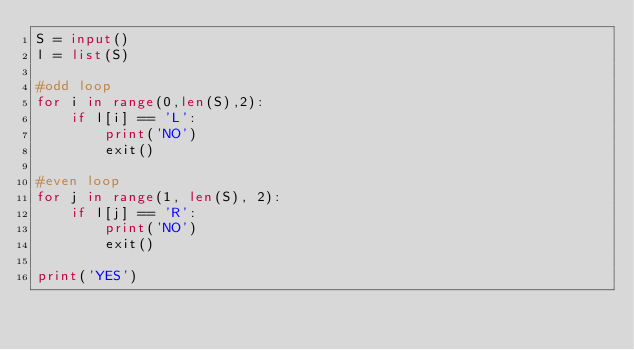<code> <loc_0><loc_0><loc_500><loc_500><_Python_>S = input()
l = list(S)

#odd loop
for i in range(0,len(S),2):
    if l[i] == 'L':
        print('NO')
        exit()

#even loop
for j in range(1, len(S), 2):
    if l[j] == 'R':
        print('NO')
        exit()

print('YES')</code> 